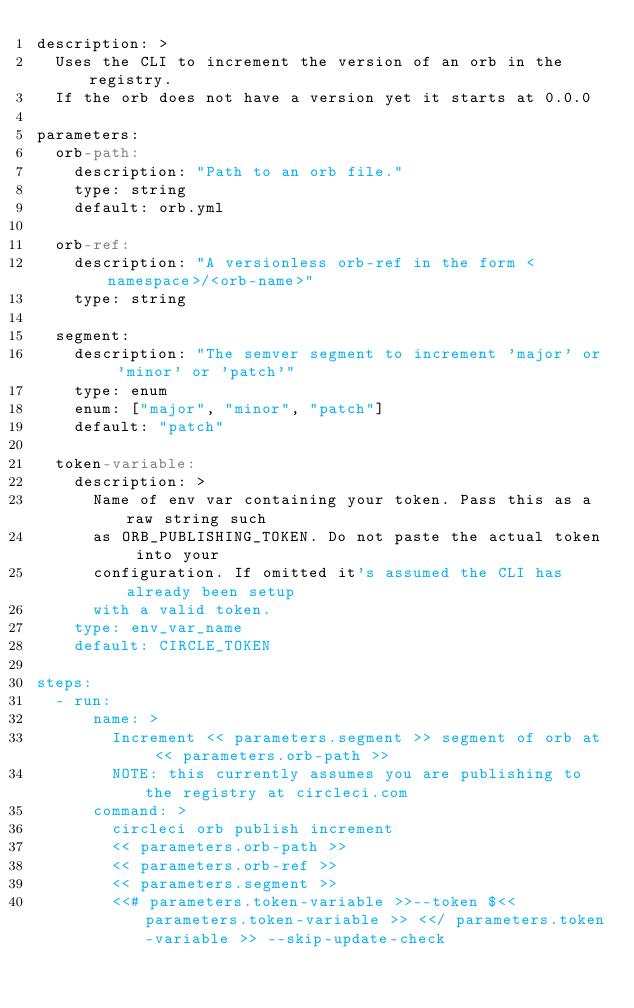Convert code to text. <code><loc_0><loc_0><loc_500><loc_500><_YAML_>description: >
  Uses the CLI to increment the version of an orb in the registry.
  If the orb does not have a version yet it starts at 0.0.0

parameters:
  orb-path:
    description: "Path to an orb file."
    type: string
    default: orb.yml

  orb-ref:
    description: "A versionless orb-ref in the form <namespace>/<orb-name>"
    type: string

  segment:
    description: "The semver segment to increment 'major' or 'minor' or 'patch'"
    type: enum
    enum: ["major", "minor", "patch"]
    default: "patch"

  token-variable:
    description: >
      Name of env var containing your token. Pass this as a raw string such
      as ORB_PUBLISHING_TOKEN. Do not paste the actual token into your
      configuration. If omitted it's assumed the CLI has already been setup
      with a valid token.
    type: env_var_name
    default: CIRCLE_TOKEN

steps:
  - run:
      name: >
        Increment << parameters.segment >> segment of orb at << parameters.orb-path >>
        NOTE: this currently assumes you are publishing to the registry at circleci.com
      command: >
        circleci orb publish increment
        << parameters.orb-path >>
        << parameters.orb-ref >>
        << parameters.segment >>
        <<# parameters.token-variable >>--token $<< parameters.token-variable >> <</ parameters.token-variable >> --skip-update-check
</code> 